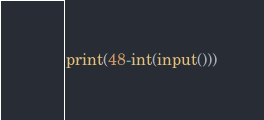Convert code to text. <code><loc_0><loc_0><loc_500><loc_500><_Python_>print(48-int(input()))</code> 